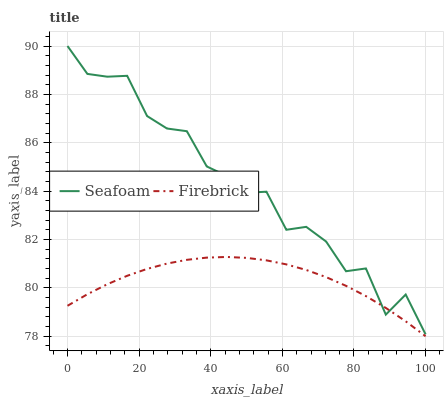Does Firebrick have the minimum area under the curve?
Answer yes or no. Yes. Does Seafoam have the maximum area under the curve?
Answer yes or no. Yes. Does Seafoam have the minimum area under the curve?
Answer yes or no. No. Is Firebrick the smoothest?
Answer yes or no. Yes. Is Seafoam the roughest?
Answer yes or no. Yes. Is Seafoam the smoothest?
Answer yes or no. No. Does Firebrick have the lowest value?
Answer yes or no. Yes. Does Seafoam have the lowest value?
Answer yes or no. No. Does Seafoam have the highest value?
Answer yes or no. Yes. Does Firebrick intersect Seafoam?
Answer yes or no. Yes. Is Firebrick less than Seafoam?
Answer yes or no. No. Is Firebrick greater than Seafoam?
Answer yes or no. No. 